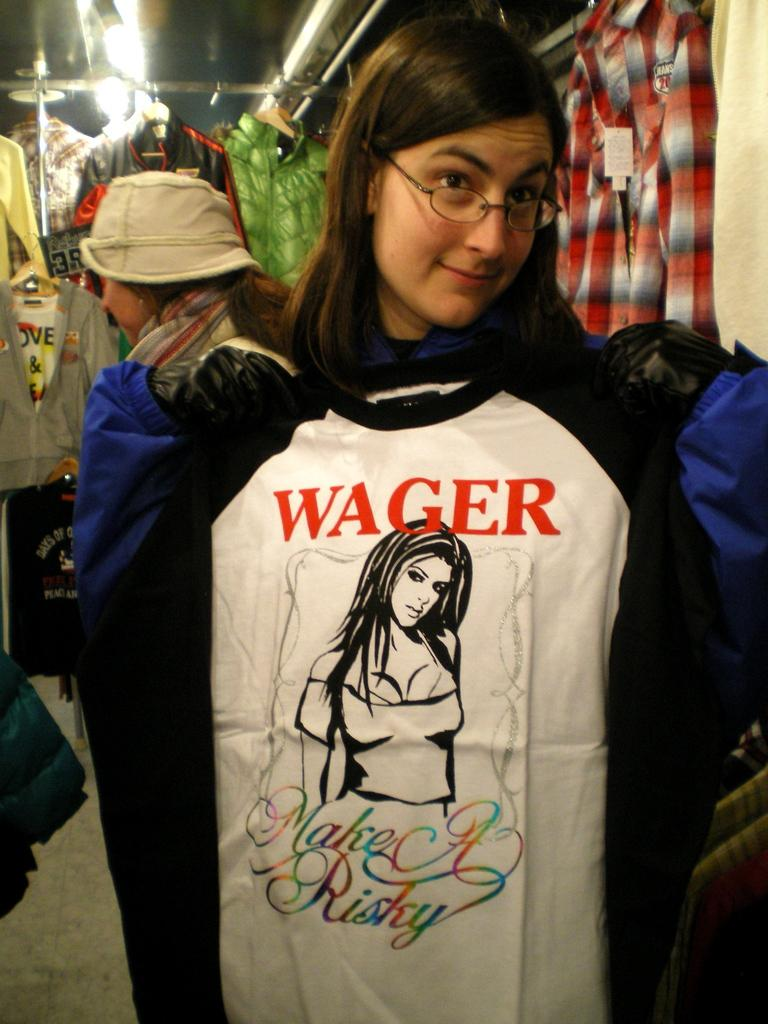Who is the main subject in the foreground of the image? There is a girl in the foreground of the image. What is the girl holding in the image? The girl is holding a T-shirt. What can be seen in the background of the image? There are clothes and at least one lamp in the background of the image. Are there any other people visible in the image? Yes, there is a lady in the background of the image. What type of shoes can be seen on the girl's toes in the image? There is no visible footwear on the girl's toes in the image. How does the digestion process of the girl appear to be in the image? The image does not provide any information about the girl's digestion process. 